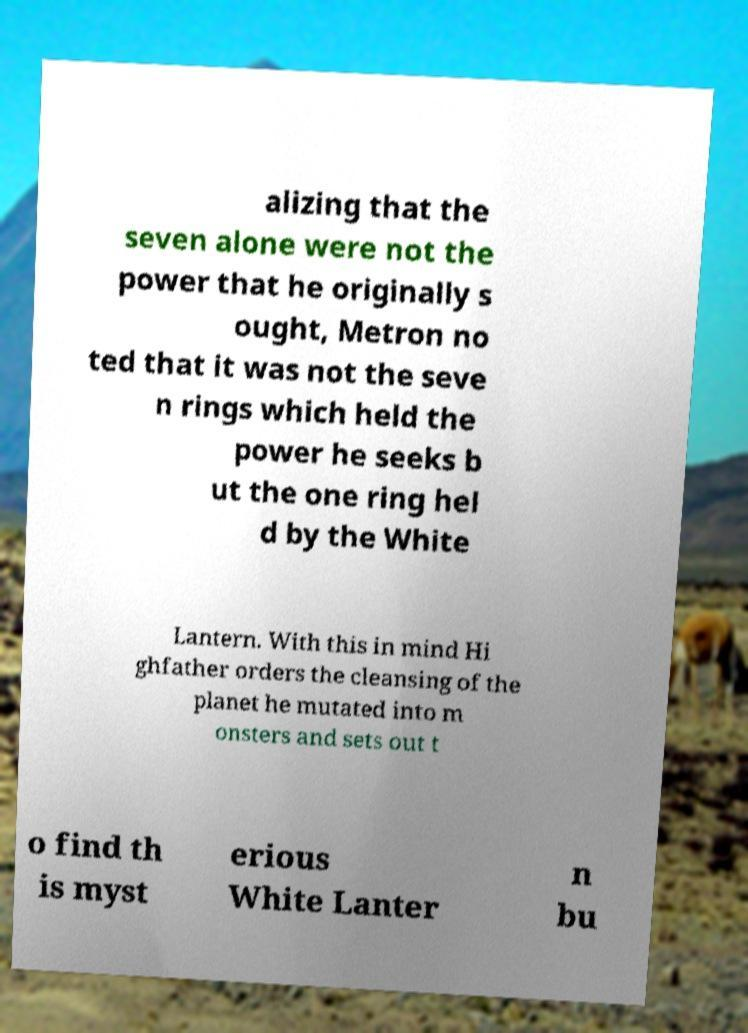Can you read and provide the text displayed in the image?This photo seems to have some interesting text. Can you extract and type it out for me? alizing that the seven alone were not the power that he originally s ought, Metron no ted that it was not the seve n rings which held the power he seeks b ut the one ring hel d by the White Lantern. With this in mind Hi ghfather orders the cleansing of the planet he mutated into m onsters and sets out t o find th is myst erious White Lanter n bu 